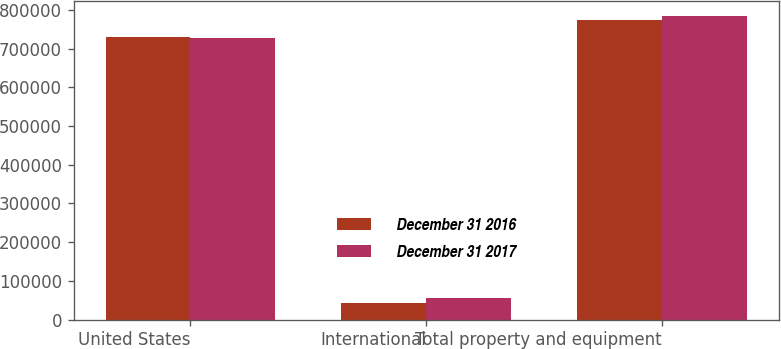Convert chart to OTSL. <chart><loc_0><loc_0><loc_500><loc_500><stacked_bar_chart><ecel><fcel>United States<fcel>International<fcel>Total property and equipment<nl><fcel>December 31 2016<fcel>730262<fcel>43453<fcel>773715<nl><fcel>December 31 2017<fcel>728429<fcel>55472<fcel>783901<nl></chart> 